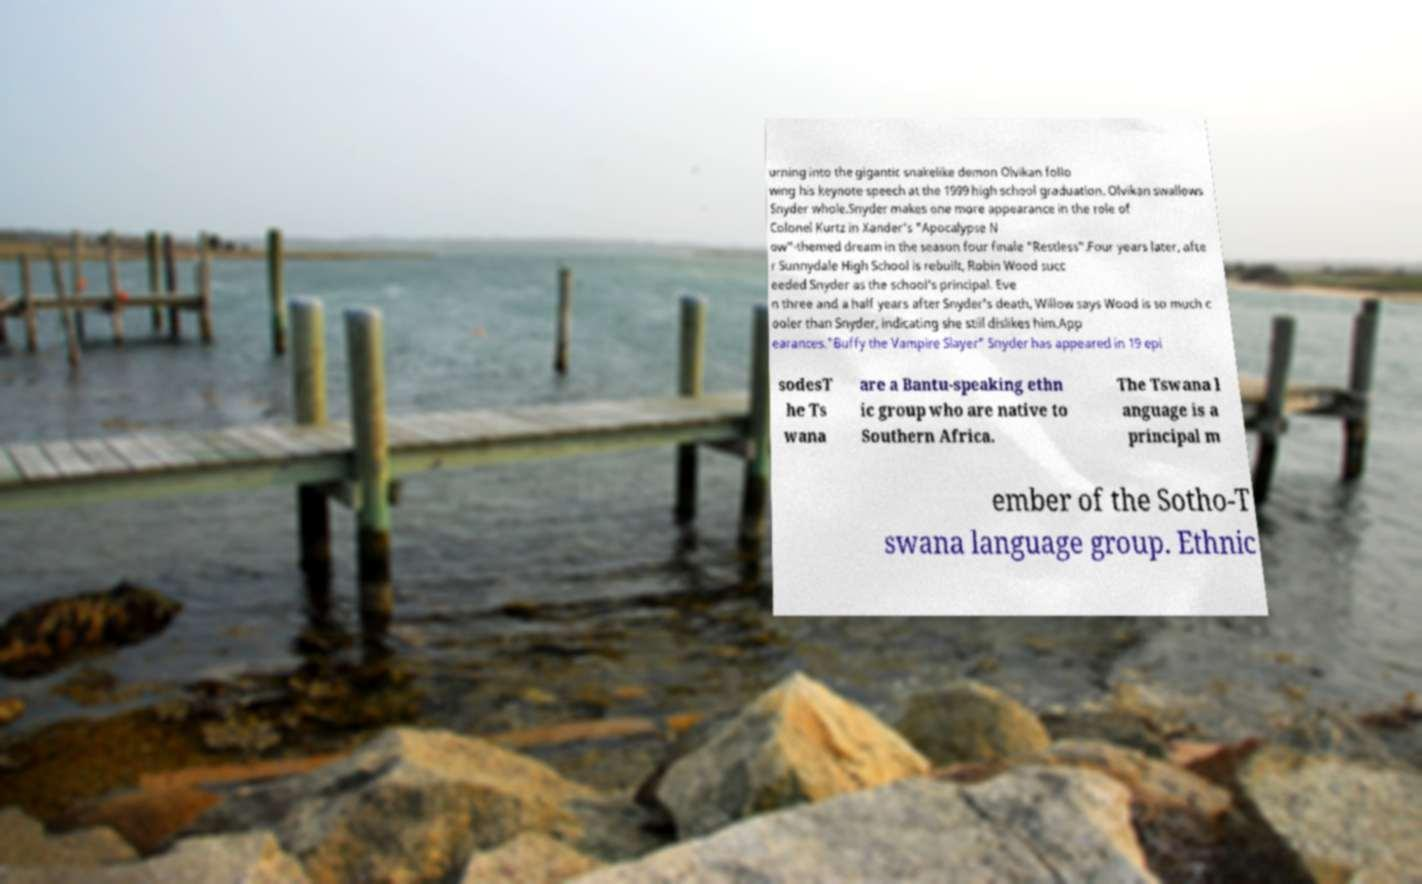Please read and relay the text visible in this image. What does it say? urning into the gigantic snakelike demon Olvikan follo wing his keynote speech at the 1999 high school graduation. Olvikan swallows Snyder whole.Snyder makes one more appearance in the role of Colonel Kurtz in Xander's "Apocalypse N ow"-themed dream in the season four finale "Restless".Four years later, afte r Sunnydale High School is rebuilt, Robin Wood succ eeded Snyder as the school's principal. Eve n three and a half years after Snyder's death, Willow says Wood is so much c ooler than Snyder, indicating she still dislikes him.App earances."Buffy the Vampire Slayer" Snyder has appeared in 19 epi sodesT he Ts wana are a Bantu-speaking ethn ic group who are native to Southern Africa. The Tswana l anguage is a principal m ember of the Sotho-T swana language group. Ethnic 